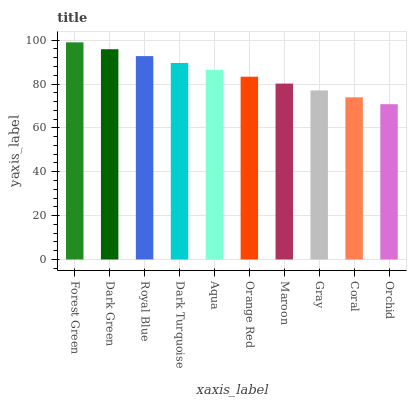Is Orchid the minimum?
Answer yes or no. Yes. Is Forest Green the maximum?
Answer yes or no. Yes. Is Dark Green the minimum?
Answer yes or no. No. Is Dark Green the maximum?
Answer yes or no. No. Is Forest Green greater than Dark Green?
Answer yes or no. Yes. Is Dark Green less than Forest Green?
Answer yes or no. Yes. Is Dark Green greater than Forest Green?
Answer yes or no. No. Is Forest Green less than Dark Green?
Answer yes or no. No. Is Aqua the high median?
Answer yes or no. Yes. Is Orange Red the low median?
Answer yes or no. Yes. Is Royal Blue the high median?
Answer yes or no. No. Is Aqua the low median?
Answer yes or no. No. 